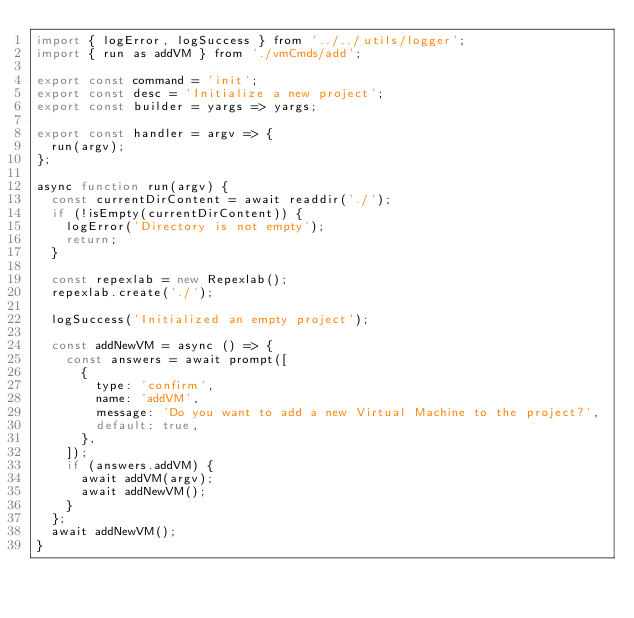Convert code to text. <code><loc_0><loc_0><loc_500><loc_500><_JavaScript_>import { logError, logSuccess } from '../../utils/logger';
import { run as addVM } from './vmCmds/add';

export const command = 'init';
export const desc = 'Initialize a new project';
export const builder = yargs => yargs;

export const handler = argv => {
  run(argv);
};

async function run(argv) {
  const currentDirContent = await readdir('./');
  if (!isEmpty(currentDirContent)) {
    logError('Directory is not empty');
    return;
  }

  const repexlab = new Repexlab();
  repexlab.create('./');

  logSuccess('Initialized an empty project');

  const addNewVM = async () => {
    const answers = await prompt([
      {
        type: 'confirm',
        name: 'addVM',
        message: 'Do you want to add a new Virtual Machine to the project?',
        default: true,
      },
    ]);
    if (answers.addVM) {
      await addVM(argv);
      await addNewVM();
    }
  };
  await addNewVM();
}
</code> 